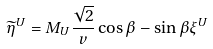<formula> <loc_0><loc_0><loc_500><loc_500>\widetilde { \eta } ^ { U } = M _ { U } \frac { \sqrt { 2 } } { v } \cos \beta - \sin \beta \xi ^ { U }</formula> 